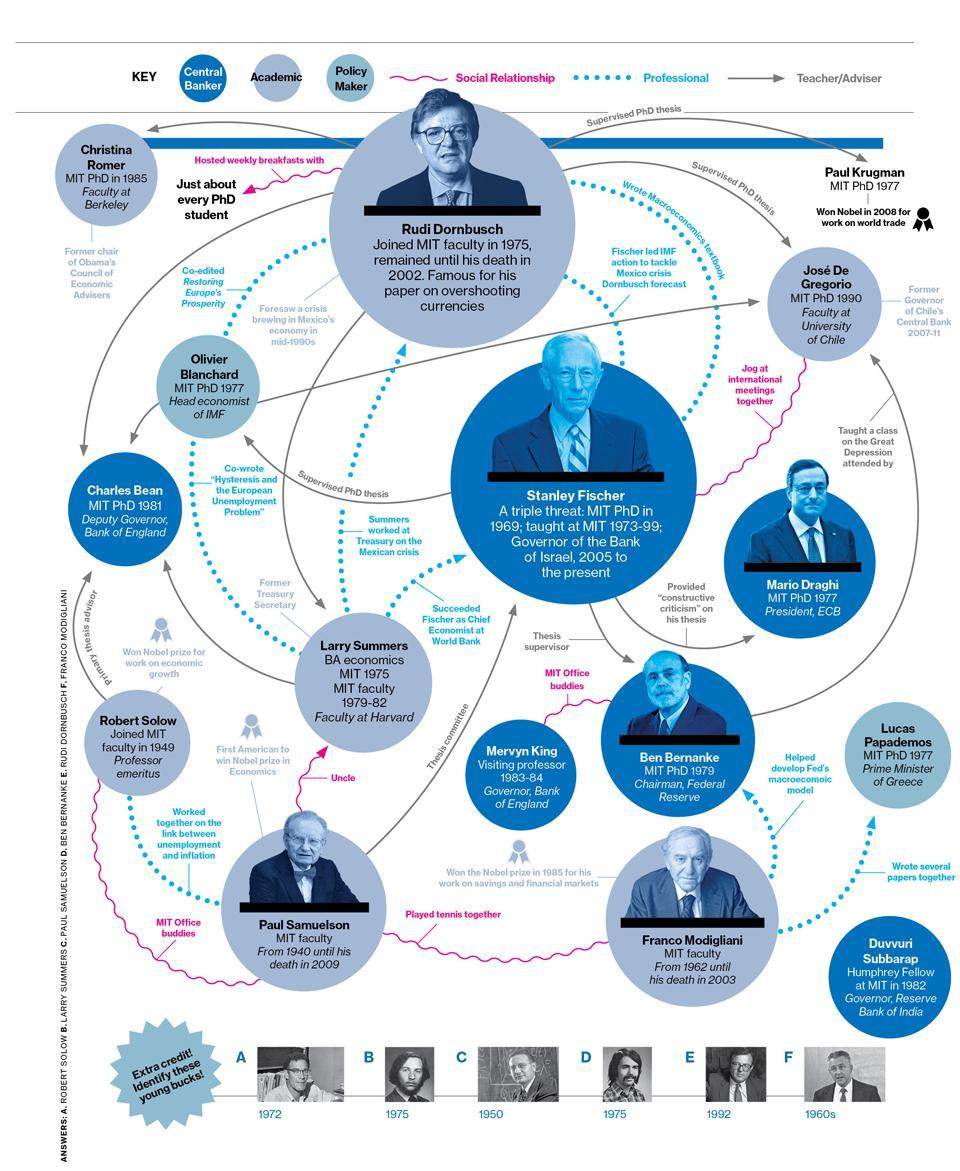Which is the person who worked as MIT Faculty from 1962 until his death in 2003?
Answer the question with a short phrase. Franco Modigliani Who is the policy maker of Charles Bean? Olivier Blanchard Who is the uncle of Larry Summers? Paul Samuelson How many Policy makers are listed in the infographic? 2 